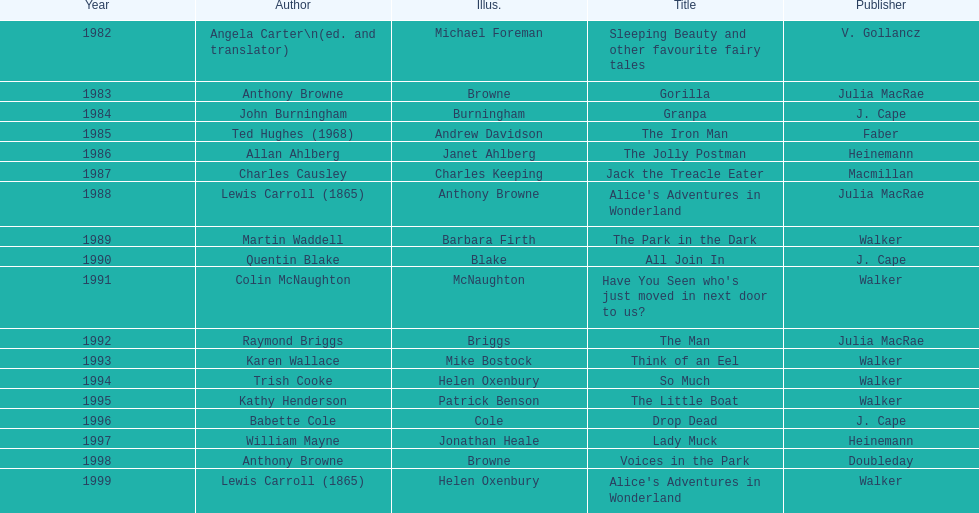Which book won the award a total of 2 times? Alice's Adventures in Wonderland. 